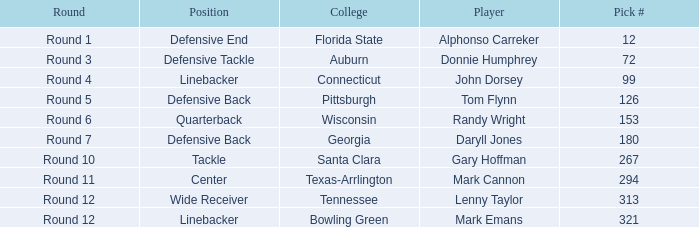In what Round was Pick #12 drafted? Round 1. 